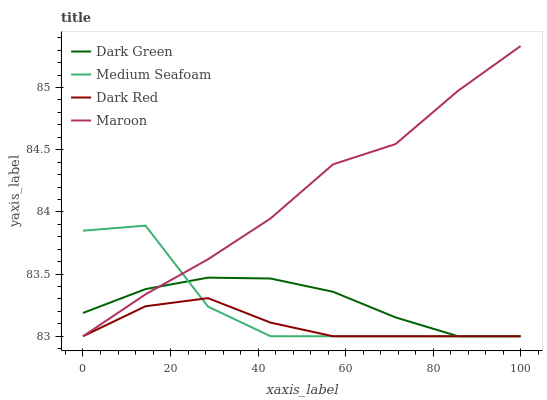Does Dark Red have the minimum area under the curve?
Answer yes or no. Yes. Does Maroon have the maximum area under the curve?
Answer yes or no. Yes. Does Medium Seafoam have the minimum area under the curve?
Answer yes or no. No. Does Medium Seafoam have the maximum area under the curve?
Answer yes or no. No. Is Dark Green the smoothest?
Answer yes or no. Yes. Is Medium Seafoam the roughest?
Answer yes or no. Yes. Is Maroon the smoothest?
Answer yes or no. No. Is Maroon the roughest?
Answer yes or no. No. Does Dark Red have the lowest value?
Answer yes or no. Yes. Does Maroon have the highest value?
Answer yes or no. Yes. Does Medium Seafoam have the highest value?
Answer yes or no. No. Does Dark Green intersect Maroon?
Answer yes or no. Yes. Is Dark Green less than Maroon?
Answer yes or no. No. Is Dark Green greater than Maroon?
Answer yes or no. No. 